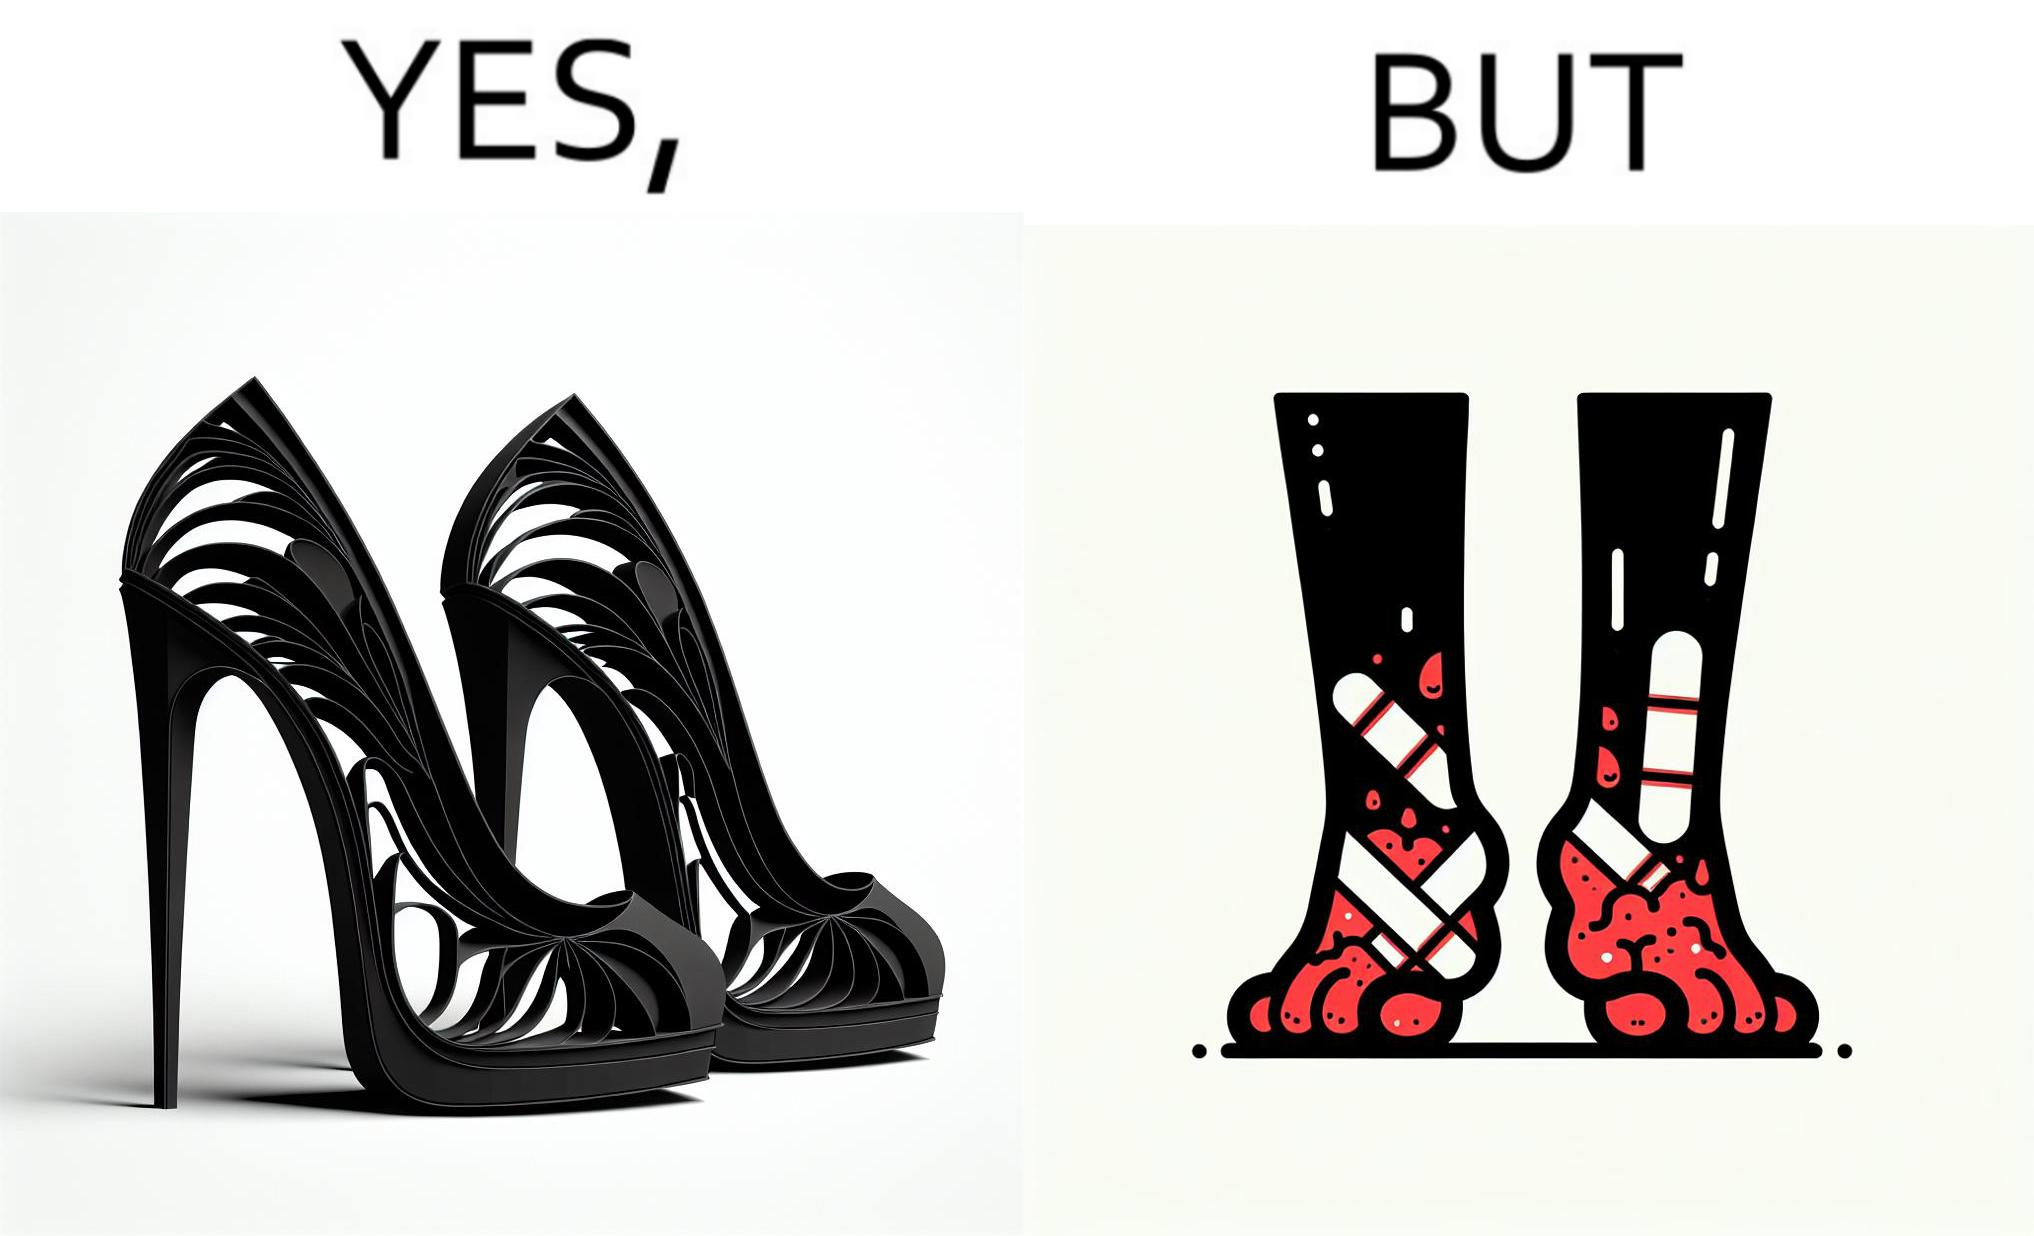Explain why this image is satirical. The images are funny since they show how the prettiest footwears like high heels, end up causing a lot of physical discomfort to the user, all in the name fashion 